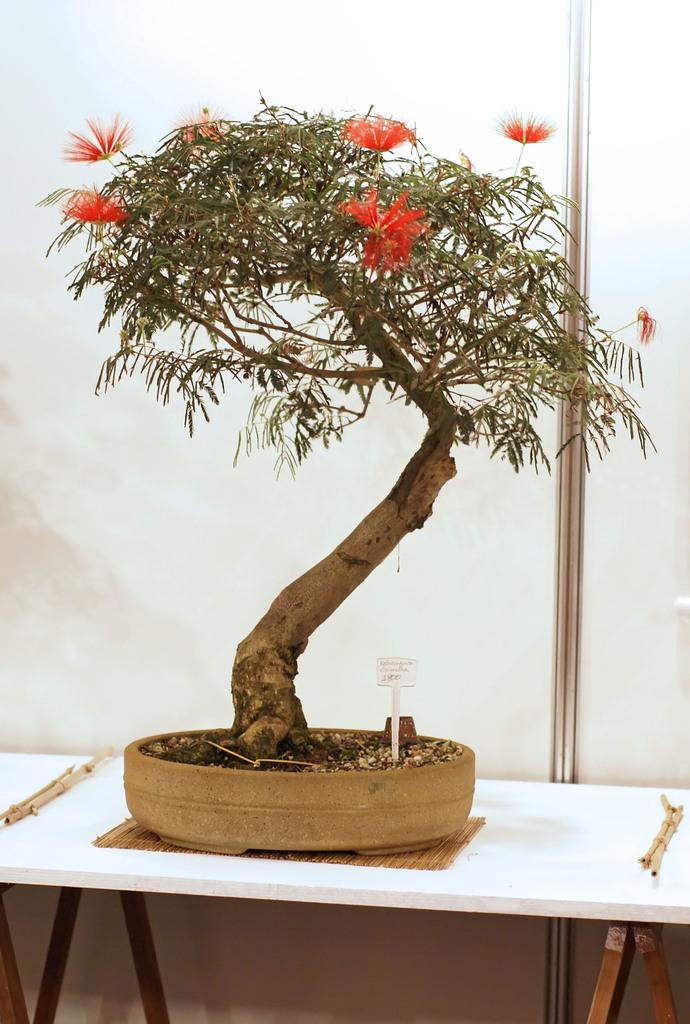What is the main object in the center of the image? There is a table in the center of the image. What is placed on the table? There is a pot, a plant, flowers, a board, and sticks on the table. What can be seen in the background of the image? There is a wall in the background of the image. What news does the mother share with her child in the image? There is no mother or child present in the image, and therefore no news can be shared. 